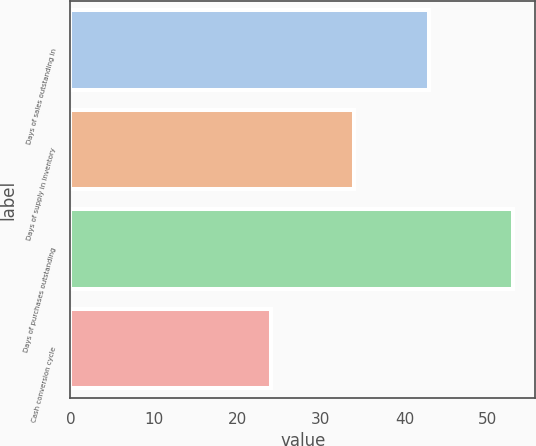<chart> <loc_0><loc_0><loc_500><loc_500><bar_chart><fcel>Days of sales outstanding in<fcel>Days of supply in inventory<fcel>Days of purchases outstanding<fcel>Cash conversion cycle<nl><fcel>43<fcel>34<fcel>53<fcel>24<nl></chart> 